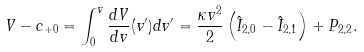Convert formula to latex. <formula><loc_0><loc_0><loc_500><loc_500>V - c _ { + 0 } = \int _ { 0 } ^ { v } \frac { d V } { d v } ( v ^ { \prime } ) d v ^ { \prime } = \frac { \kappa v ^ { 2 } } { 2 } \left ( \hat { I } _ { 2 , 0 } - \hat { I } _ { 2 , 1 } \right ) + P _ { 2 , 2 } .</formula> 